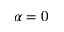<formula> <loc_0><loc_0><loc_500><loc_500>\alpha = 0</formula> 